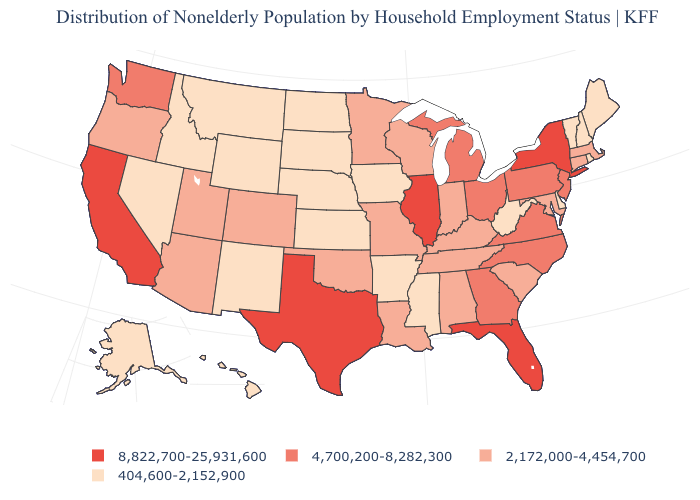Which states have the lowest value in the MidWest?
Be succinct. Iowa, Kansas, Nebraska, North Dakota, South Dakota. Name the states that have a value in the range 404,600-2,152,900?
Quick response, please. Alaska, Arkansas, Delaware, Hawaii, Idaho, Iowa, Kansas, Maine, Mississippi, Montana, Nebraska, Nevada, New Hampshire, New Mexico, North Dakota, Rhode Island, South Dakota, Vermont, West Virginia, Wyoming. Name the states that have a value in the range 4,700,200-8,282,300?
Quick response, please. Georgia, Michigan, New Jersey, North Carolina, Ohio, Pennsylvania, Virginia, Washington. Name the states that have a value in the range 404,600-2,152,900?
Be succinct. Alaska, Arkansas, Delaware, Hawaii, Idaho, Iowa, Kansas, Maine, Mississippi, Montana, Nebraska, Nevada, New Hampshire, New Mexico, North Dakota, Rhode Island, South Dakota, Vermont, West Virginia, Wyoming. Name the states that have a value in the range 2,172,000-4,454,700?
Answer briefly. Alabama, Arizona, Colorado, Connecticut, Indiana, Kentucky, Louisiana, Maryland, Massachusetts, Minnesota, Missouri, Oklahoma, Oregon, South Carolina, Tennessee, Utah, Wisconsin. Does Texas have a higher value than California?
Keep it brief. No. What is the value of Iowa?
Answer briefly. 404,600-2,152,900. What is the value of Indiana?
Give a very brief answer. 2,172,000-4,454,700. Which states have the lowest value in the USA?
Concise answer only. Alaska, Arkansas, Delaware, Hawaii, Idaho, Iowa, Kansas, Maine, Mississippi, Montana, Nebraska, Nevada, New Hampshire, New Mexico, North Dakota, Rhode Island, South Dakota, Vermont, West Virginia, Wyoming. What is the value of Indiana?
Quick response, please. 2,172,000-4,454,700. What is the lowest value in the South?
Answer briefly. 404,600-2,152,900. Does Rhode Island have the highest value in the Northeast?
Give a very brief answer. No. Name the states that have a value in the range 404,600-2,152,900?
Concise answer only. Alaska, Arkansas, Delaware, Hawaii, Idaho, Iowa, Kansas, Maine, Mississippi, Montana, Nebraska, Nevada, New Hampshire, New Mexico, North Dakota, Rhode Island, South Dakota, Vermont, West Virginia, Wyoming. What is the highest value in the MidWest ?
Write a very short answer. 8,822,700-25,931,600. Which states hav the highest value in the Northeast?
Write a very short answer. New York. 